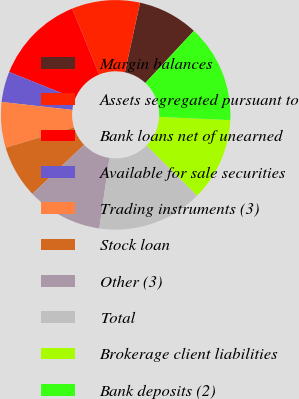Convert chart. <chart><loc_0><loc_0><loc_500><loc_500><pie_chart><fcel>Margin balances<fcel>Assets segregated pursuant to<fcel>Bank loans net of unearned<fcel>Available for sale securities<fcel>Trading instruments (3)<fcel>Stock loan<fcel>Other (3)<fcel>Total<fcel>Brokerage client liabilities<fcel>Bank deposits (2)<nl><fcel>8.52%<fcel>9.58%<fcel>12.74%<fcel>4.3%<fcel>6.41%<fcel>7.47%<fcel>10.63%<fcel>14.85%<fcel>11.69%<fcel>13.8%<nl></chart> 